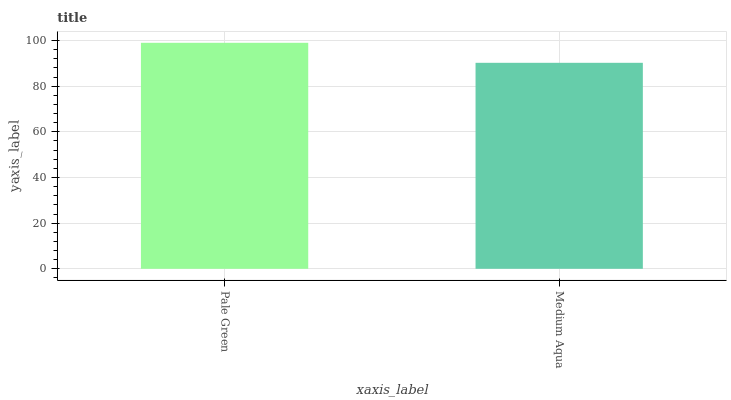Is Medium Aqua the minimum?
Answer yes or no. Yes. Is Pale Green the maximum?
Answer yes or no. Yes. Is Medium Aqua the maximum?
Answer yes or no. No. Is Pale Green greater than Medium Aqua?
Answer yes or no. Yes. Is Medium Aqua less than Pale Green?
Answer yes or no. Yes. Is Medium Aqua greater than Pale Green?
Answer yes or no. No. Is Pale Green less than Medium Aqua?
Answer yes or no. No. Is Pale Green the high median?
Answer yes or no. Yes. Is Medium Aqua the low median?
Answer yes or no. Yes. Is Medium Aqua the high median?
Answer yes or no. No. Is Pale Green the low median?
Answer yes or no. No. 